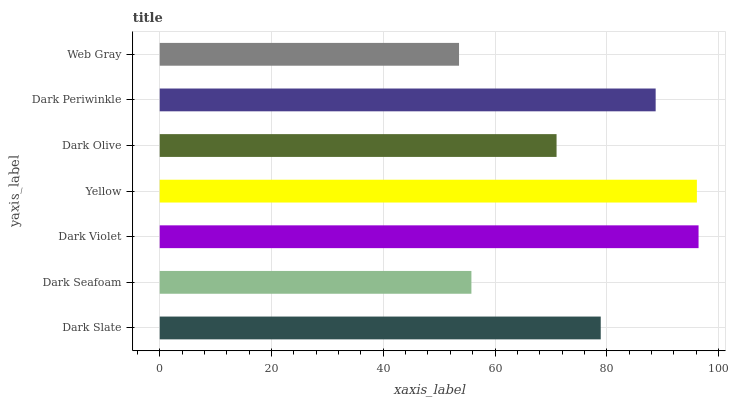Is Web Gray the minimum?
Answer yes or no. Yes. Is Dark Violet the maximum?
Answer yes or no. Yes. Is Dark Seafoam the minimum?
Answer yes or no. No. Is Dark Seafoam the maximum?
Answer yes or no. No. Is Dark Slate greater than Dark Seafoam?
Answer yes or no. Yes. Is Dark Seafoam less than Dark Slate?
Answer yes or no. Yes. Is Dark Seafoam greater than Dark Slate?
Answer yes or no. No. Is Dark Slate less than Dark Seafoam?
Answer yes or no. No. Is Dark Slate the high median?
Answer yes or no. Yes. Is Dark Slate the low median?
Answer yes or no. Yes. Is Yellow the high median?
Answer yes or no. No. Is Dark Seafoam the low median?
Answer yes or no. No. 